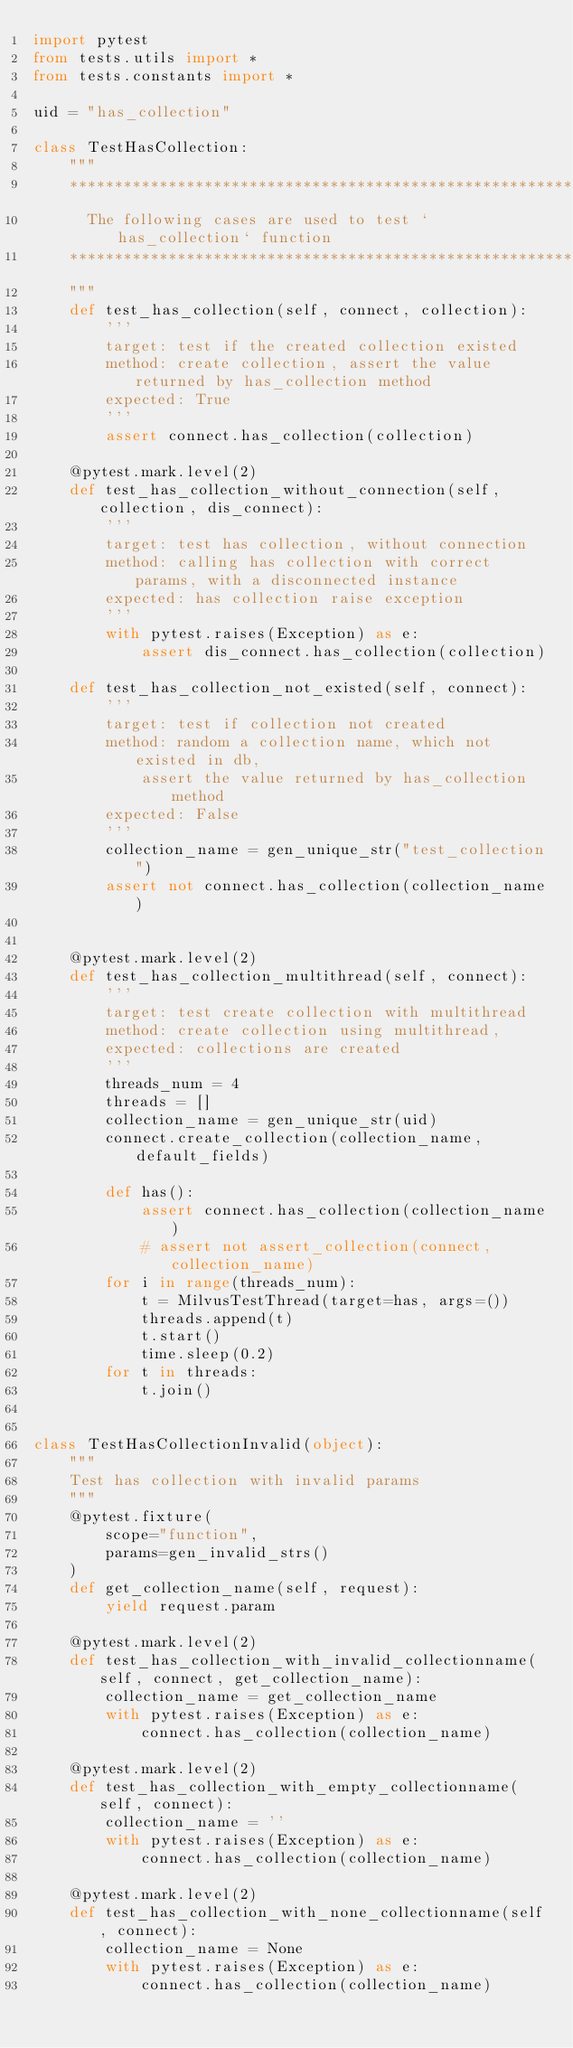<code> <loc_0><loc_0><loc_500><loc_500><_Python_>import pytest
from tests.utils import *
from tests.constants import *

uid = "has_collection"

class TestHasCollection:
    """
    ******************************************************************
      The following cases are used to test `has_collection` function
    ******************************************************************
    """
    def test_has_collection(self, connect, collection):
        '''
        target: test if the created collection existed
        method: create collection, assert the value returned by has_collection method
        expected: True
        '''
        assert connect.has_collection(collection)

    @pytest.mark.level(2)
    def test_has_collection_without_connection(self, collection, dis_connect):
        '''
        target: test has collection, without connection
        method: calling has collection with correct params, with a disconnected instance
        expected: has collection raise exception
        '''
        with pytest.raises(Exception) as e:
            assert dis_connect.has_collection(collection)

    def test_has_collection_not_existed(self, connect):
        '''
        target: test if collection not created
        method: random a collection name, which not existed in db, 
            assert the value returned by has_collection method
        expected: False
        '''
        collection_name = gen_unique_str("test_collection")
        assert not connect.has_collection(collection_name)


    @pytest.mark.level(2)
    def test_has_collection_multithread(self, connect):
        '''
        target: test create collection with multithread
        method: create collection using multithread,
        expected: collections are created
        '''
        threads_num = 4
        threads = []
        collection_name = gen_unique_str(uid)
        connect.create_collection(collection_name, default_fields)

        def has():
            assert connect.has_collection(collection_name)
            # assert not assert_collection(connect, collection_name)
        for i in range(threads_num):
            t = MilvusTestThread(target=has, args=())
            threads.append(t)
            t.start()
            time.sleep(0.2)
        for t in threads:
            t.join()


class TestHasCollectionInvalid(object):
    """
    Test has collection with invalid params
    """
    @pytest.fixture(
        scope="function",
        params=gen_invalid_strs()
    )
    def get_collection_name(self, request):
        yield request.param

    @pytest.mark.level(2)
    def test_has_collection_with_invalid_collectionname(self, connect, get_collection_name):
        collection_name = get_collection_name
        with pytest.raises(Exception) as e:
            connect.has_collection(collection_name)

    @pytest.mark.level(2)
    def test_has_collection_with_empty_collectionname(self, connect):
        collection_name = ''
        with pytest.raises(Exception) as e:
            connect.has_collection(collection_name)

    @pytest.mark.level(2)
    def test_has_collection_with_none_collectionname(self, connect):
        collection_name = None
        with pytest.raises(Exception) as e:
            connect.has_collection(collection_name)
</code> 